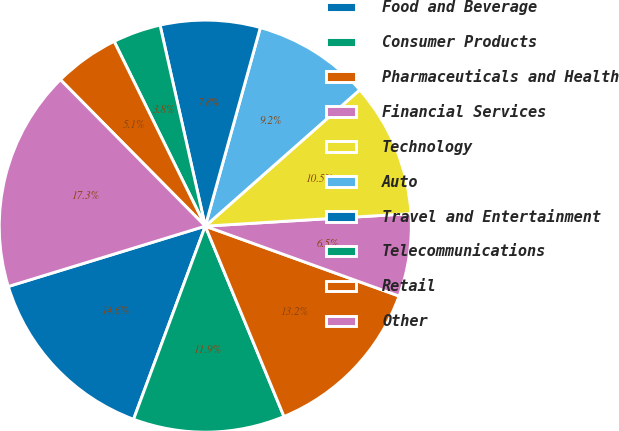<chart> <loc_0><loc_0><loc_500><loc_500><pie_chart><fcel>Food and Beverage<fcel>Consumer Products<fcel>Pharmaceuticals and Health<fcel>Financial Services<fcel>Technology<fcel>Auto<fcel>Travel and Entertainment<fcel>Telecommunications<fcel>Retail<fcel>Other<nl><fcel>14.61%<fcel>11.9%<fcel>13.25%<fcel>6.48%<fcel>10.54%<fcel>9.19%<fcel>7.83%<fcel>3.77%<fcel>5.12%<fcel>17.32%<nl></chart> 